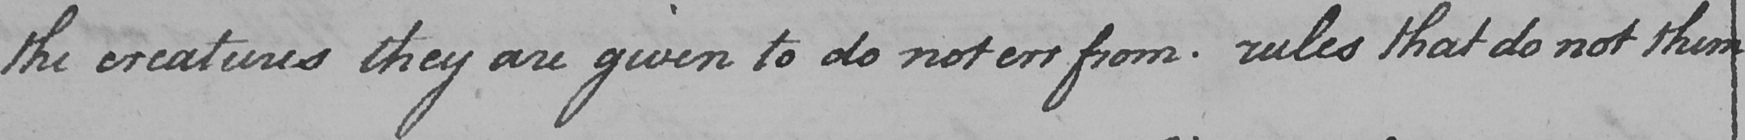What text is written in this handwritten line? the creatures they are given to do not err from . rules that do not them- 